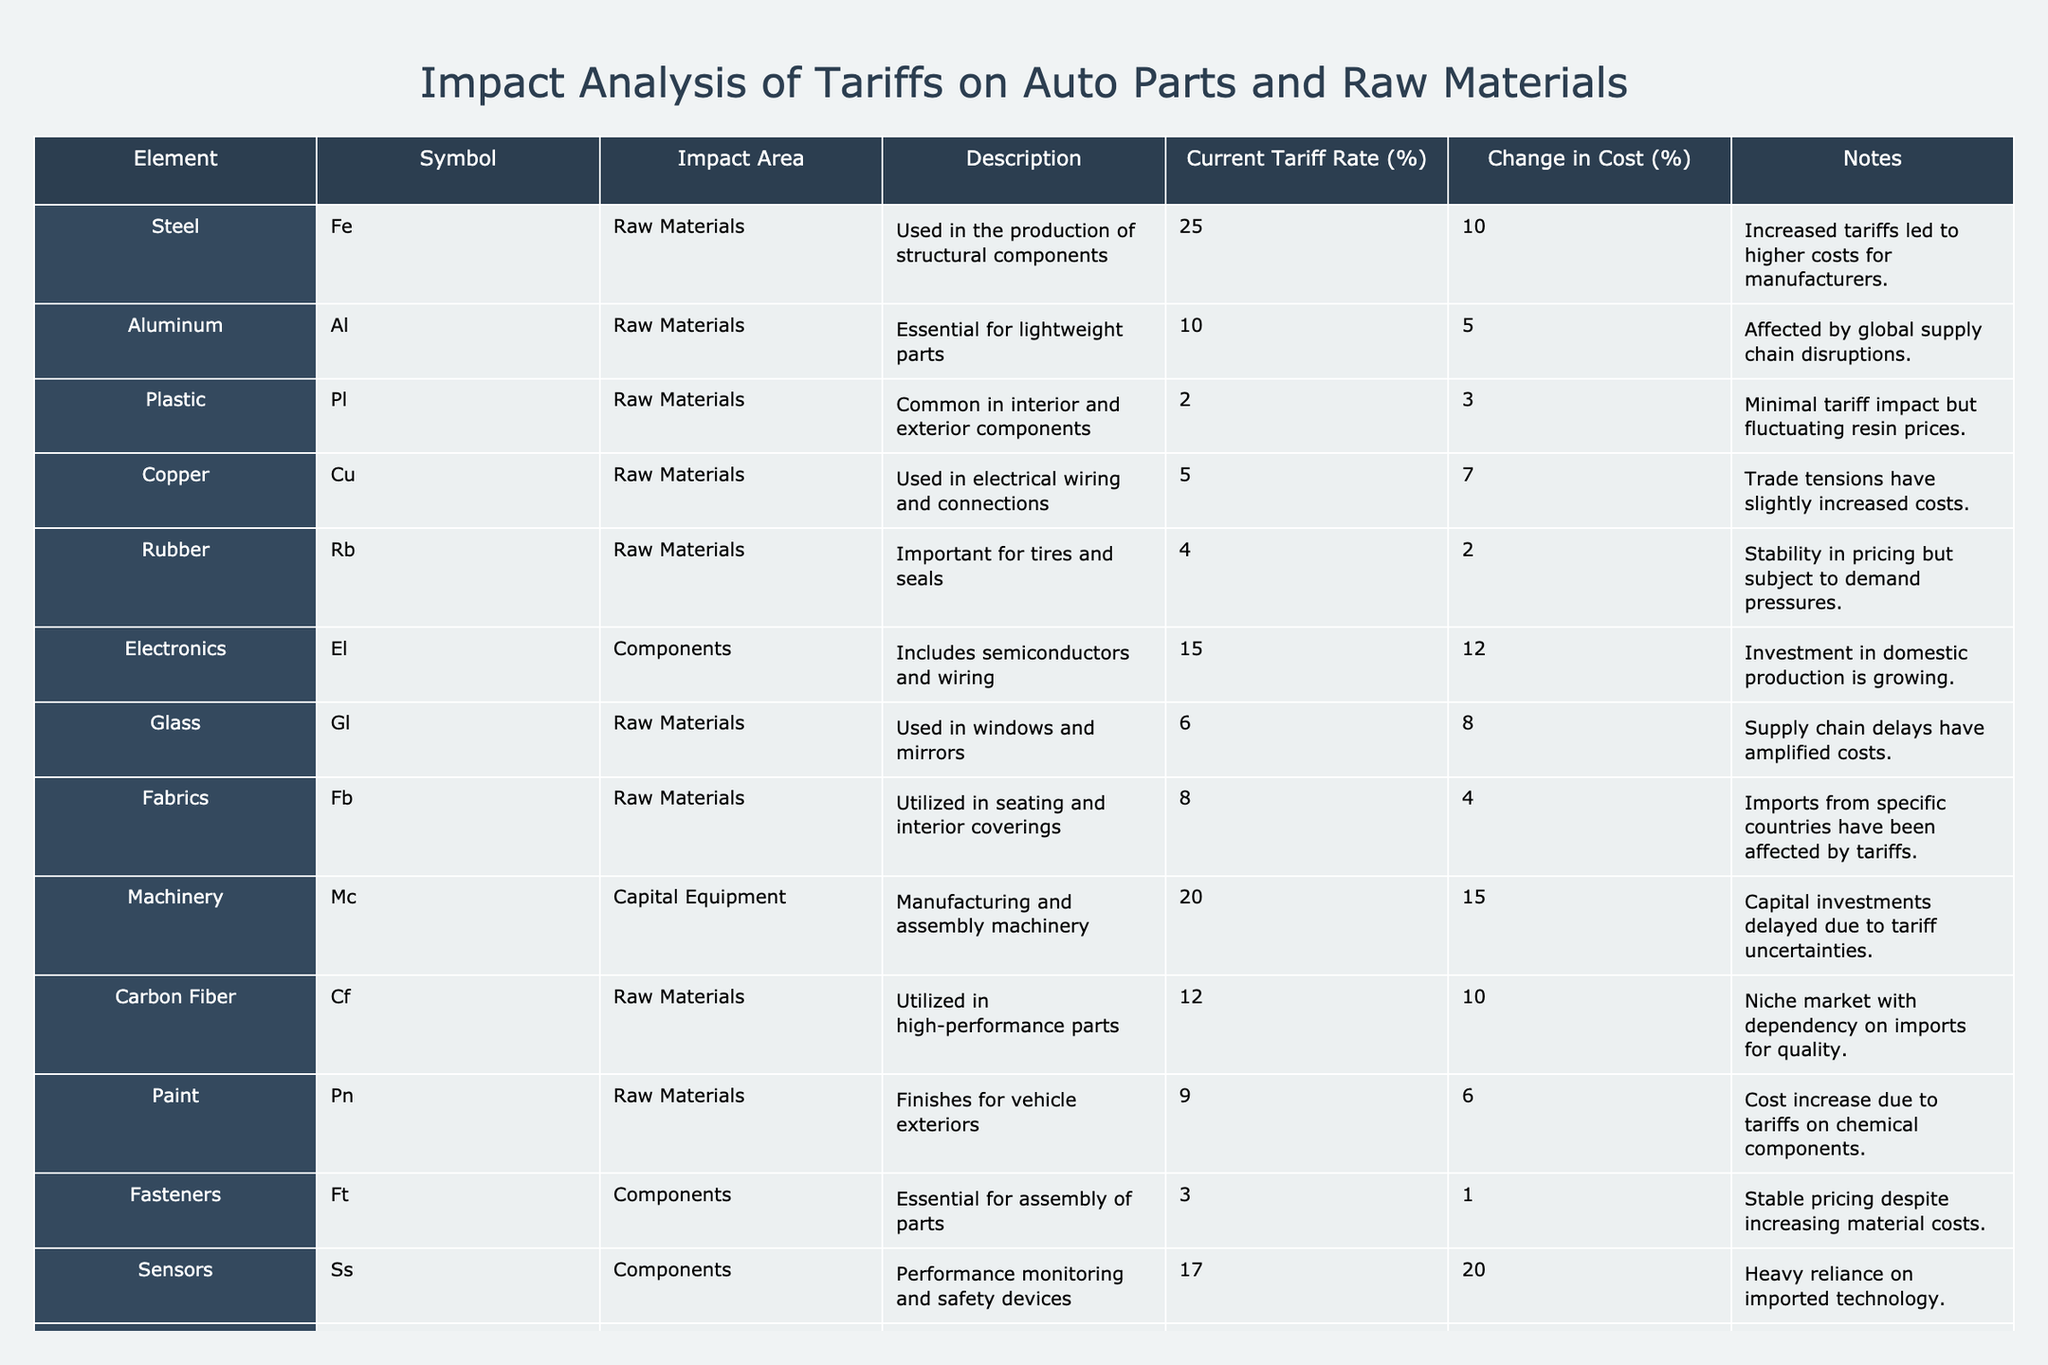What is the current tariff rate on Steel? By referring to the table, I can locate the row for Steel. The "Current Tariff Rate (%)" column indicates a value of 25% for Steel.
Answer: 25% Which raw material has the highest change in cost percentage? In the table, I will look for the "Change in Cost (%)" column among raw materials. The maximum value found is 12% for Electronics and 10% for Carbon Fiber, but Electronics is a component, not a raw material. Hence, the highest change for raw materials is 10% for Steel.
Answer: Steel Is the current tariff rate for Aluminum higher than that for Plastics? I compare the "Current Tariff Rate (%)" for Aluminum (10%) and Plastics (2%). Since 10% is greater than 2%, the statement is true.
Answer: Yes What is the average change in cost percentage for the raw materials listed in the table? I will sum the change in cost percentages of all raw materials: (10 + 5 + 3 + 7 + 2 + 8 + 4 + 10 + 6 + 9) = 54. There are 10 raw materials, so I divide 54 by 10 to find the average, which is 5.4%.
Answer: 5.4% Which component has the lowest current tariff rate? By checking the "Current Tariff Rate (%)" column for components, I see that sensors have a rate of 17%, but the lowest is fasteners at 3%.
Answer: Fasteners What is the difference in cost percentage change between Electronics and Sensors? I find the "Change in Cost (%)" for Electronics (12%) and Sensors (20%). To find the difference, I calculate 20% - 12% = 8%.
Answer: 8% Does the data indicate that the tariffs have predominantly increased costs for raw materials or components? I will evaluate the average change in cost for both categories. The average change for raw materials is 5.4%, whereas for components (12 and 20), it's higher. Thus, tariffs have more impact on components.
Answer: Yes Which raw material has the least change in cost percentage? I review the "Change in Cost (%)" for all raw materials and find that Rubber has a change of only 2%, which is the least compared to others.
Answer: Rubber 